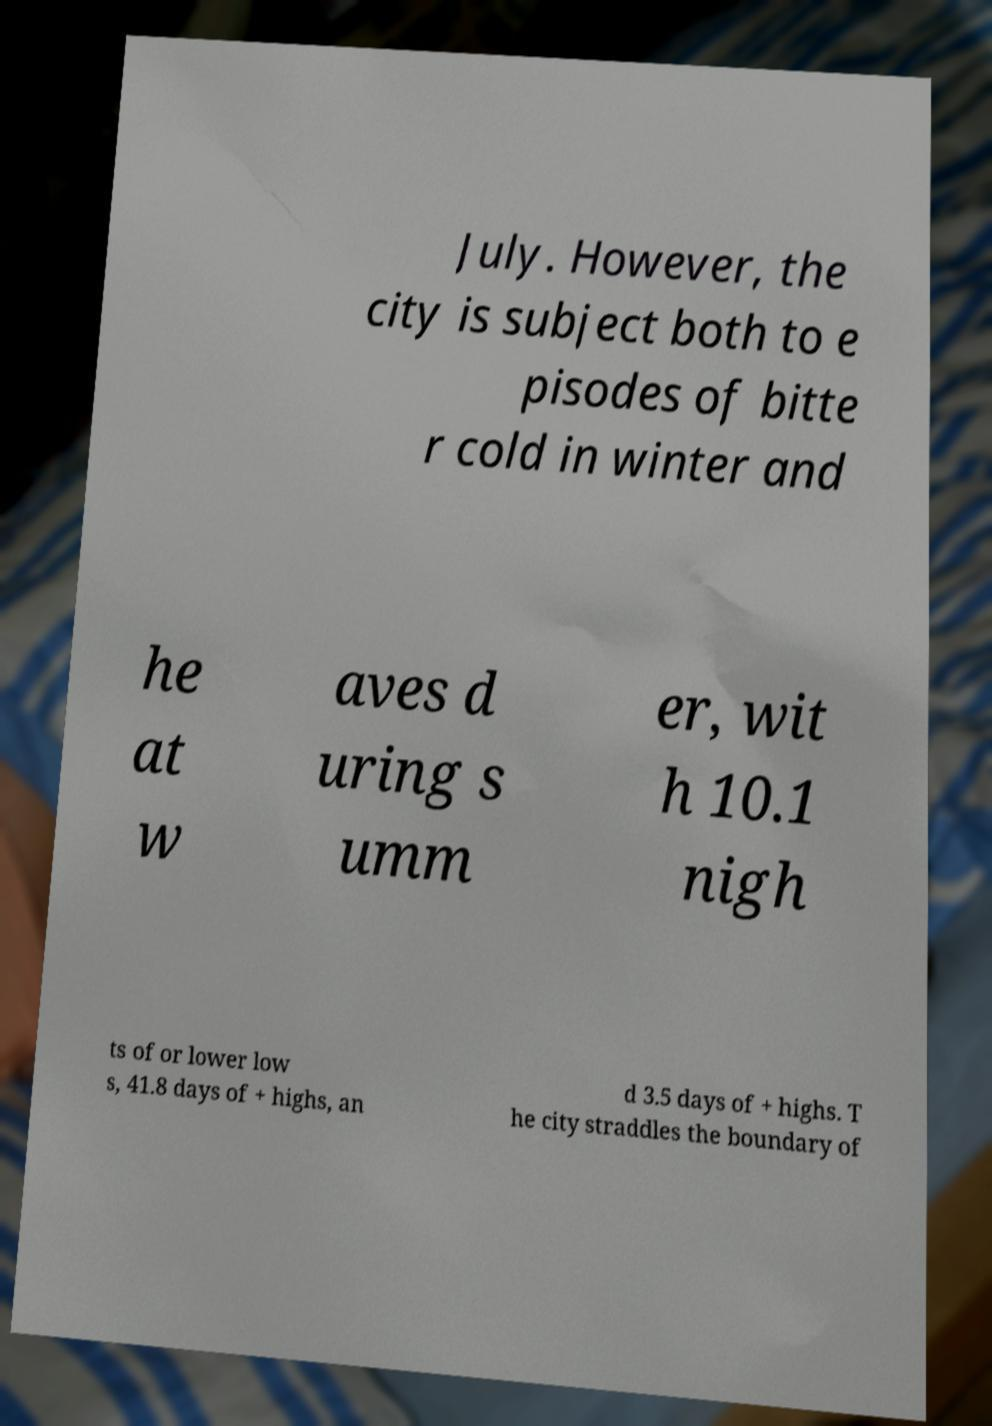Please read and relay the text visible in this image. What does it say? July. However, the city is subject both to e pisodes of bitte r cold in winter and he at w aves d uring s umm er, wit h 10.1 nigh ts of or lower low s, 41.8 days of + highs, an d 3.5 days of + highs. T he city straddles the boundary of 